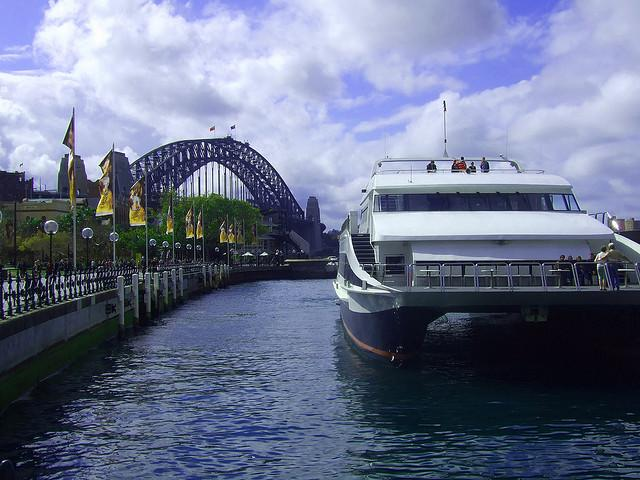Why the gap underneath the boat?

Choices:
A) stability
B) speed
C) style
D) weight reduction stability 